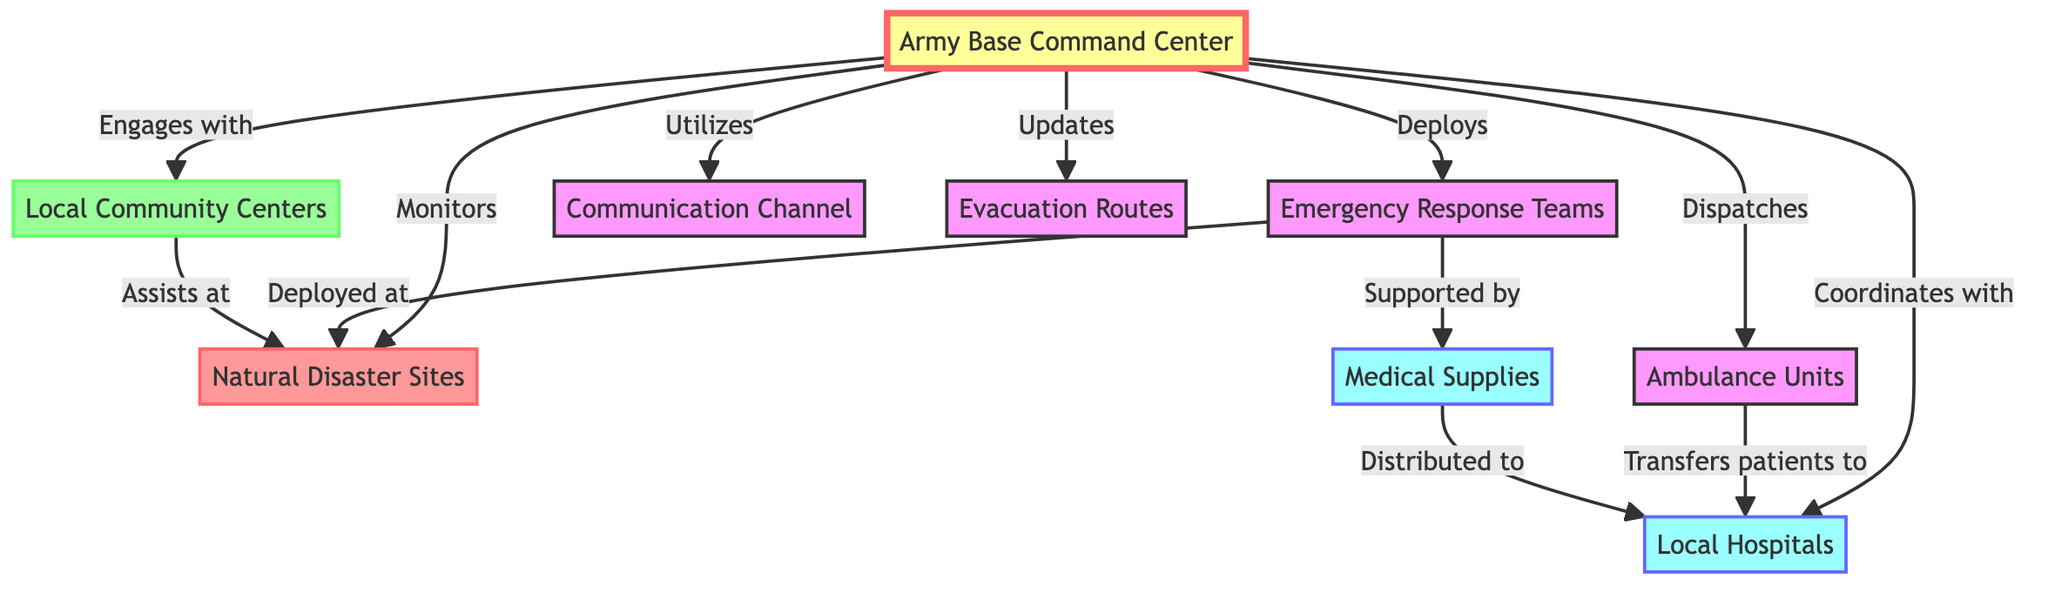What is the first node mentioned in the diagram? The first node mentioned is the "Army Base Command Center," which is the central coordinating hub for the emergency medical response plan.
Answer: Army Base Command Center How many types of emergency response units are involved? The diagram lists two types involved: "Ambulance Units" and "Emergency Response Teams," making it a total of two types.
Answer: 2 What do the ambulance units transfer patients to? According to the diagram, ambulance units transfer patients to "Local Hospitals," which are the designated facilities for patient care.
Answer: Local Hospitals Which node is connected to both the command center and disaster sites? The "Emergency Response Teams" are explicitly indicated to be deployed at disaster sites, creating a direct connection from the command center.
Answer: Emergency Response Teams What resource do emergency teams rely on at disaster sites? The diagram specifies that "Medical Supplies" are supported to the emergency teams at disaster sites, indicating their reliance on this resource for effective operation.
Answer: Medical Supplies How does the command center engage with the community? The command center engages with "Local Community Centers," allowing collaboration in response and support activities during emergencies.
Answer: Local Community Centers What is distributed to local hospitals? The diagram indicates that "Medical Supplies" are distributed to local hospitals, which is essential for patient care during emergencies.
Answer: Medical Supplies How are the evacuation routes updated? The "Army Base Command Center" is responsible for updating "Evacuation Routes," ensuring that routes are current and effective for emergency situations.
Answer: Evacuation Routes What role do local community centers play at disaster sites? The diagram shows that local community centers assist at disaster sites, promoting community involvement in response efforts.
Answer: Assists at disaster sites 